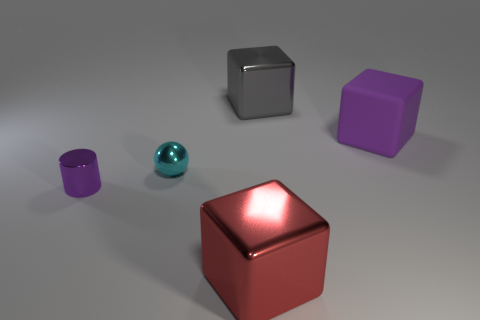Add 3 gray metallic cylinders. How many objects exist? 8 Subtract all blocks. How many objects are left? 2 Add 5 big purple matte objects. How many big purple matte objects are left? 6 Add 2 red matte spheres. How many red matte spheres exist? 2 Subtract 0 cyan blocks. How many objects are left? 5 Subtract all large purple rubber things. Subtract all small metallic cylinders. How many objects are left? 3 